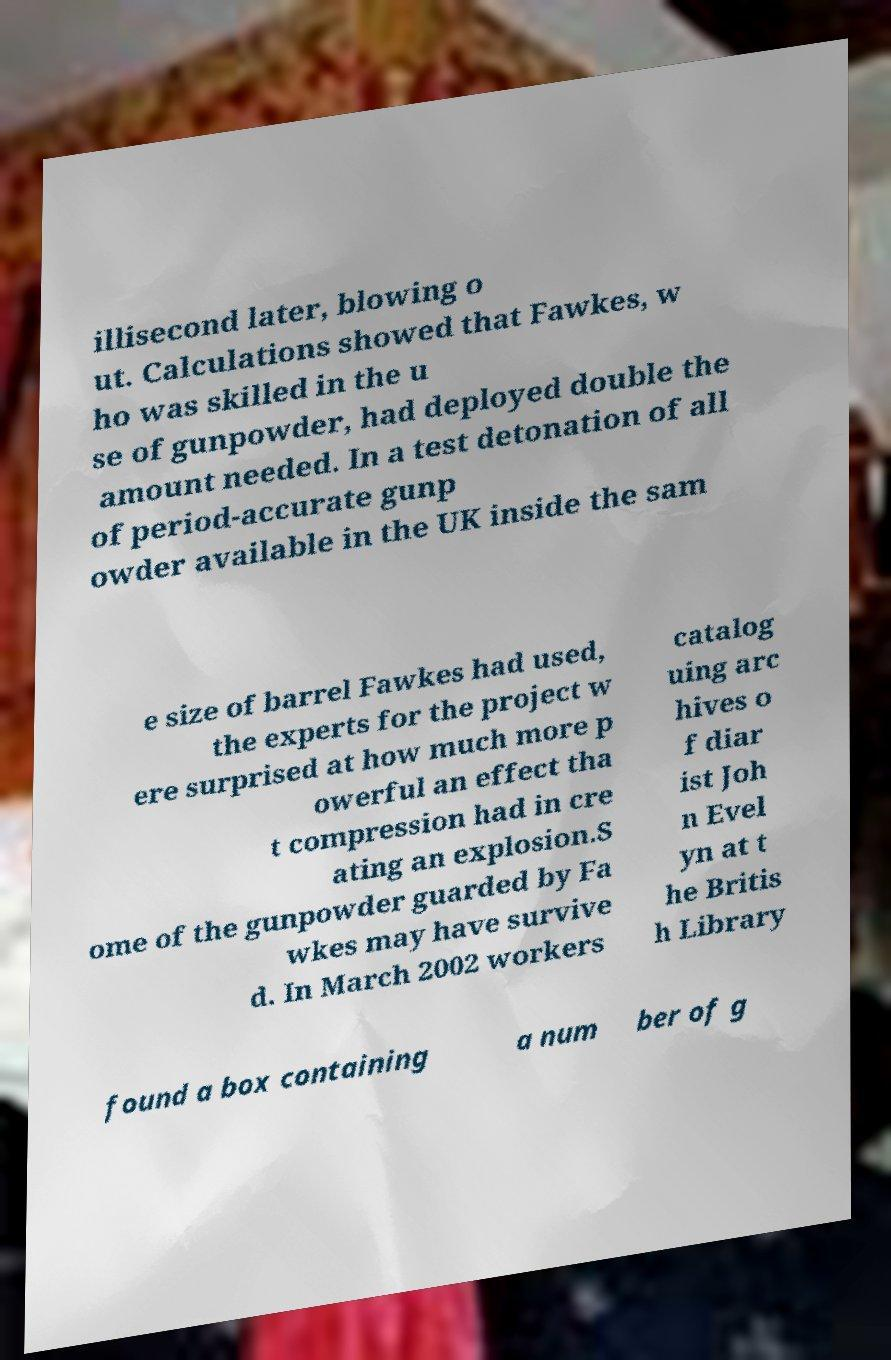Could you extract and type out the text from this image? illisecond later, blowing o ut. Calculations showed that Fawkes, w ho was skilled in the u se of gunpowder, had deployed double the amount needed. In a test detonation of all of period-accurate gunp owder available in the UK inside the sam e size of barrel Fawkes had used, the experts for the project w ere surprised at how much more p owerful an effect tha t compression had in cre ating an explosion.S ome of the gunpowder guarded by Fa wkes may have survive d. In March 2002 workers catalog uing arc hives o f diar ist Joh n Evel yn at t he Britis h Library found a box containing a num ber of g 